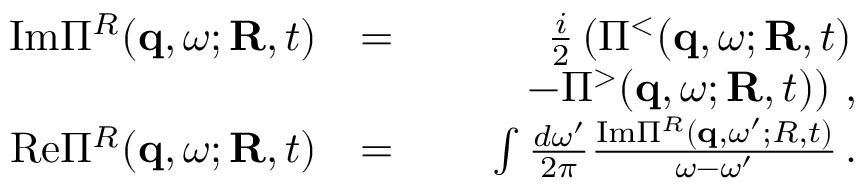<formula> <loc_0><loc_0><loc_500><loc_500>\begin{array} { r l r } { I m \Pi ^ { R } ( { q } , \omega ; { R } , t ) } & { = } & { \frac { i } { 2 } \left ( \Pi ^ { < } ( { q } , \omega ; { R } , t ) } \\ & { \quad - \Pi ^ { > } ( { q } , \omega ; { R } , t ) \right ) \, , } \\ { R e \Pi ^ { R } ( { q } , \omega ; { R } , t ) } & { = } & { \int \frac { d \omega ^ { \prime } } { 2 \pi } \frac { I m \Pi ^ { R } ( { q } , \omega ^ { \prime } ; R , t ) } { \omega - \omega ^ { \prime } } \, . } \end{array}</formula> 